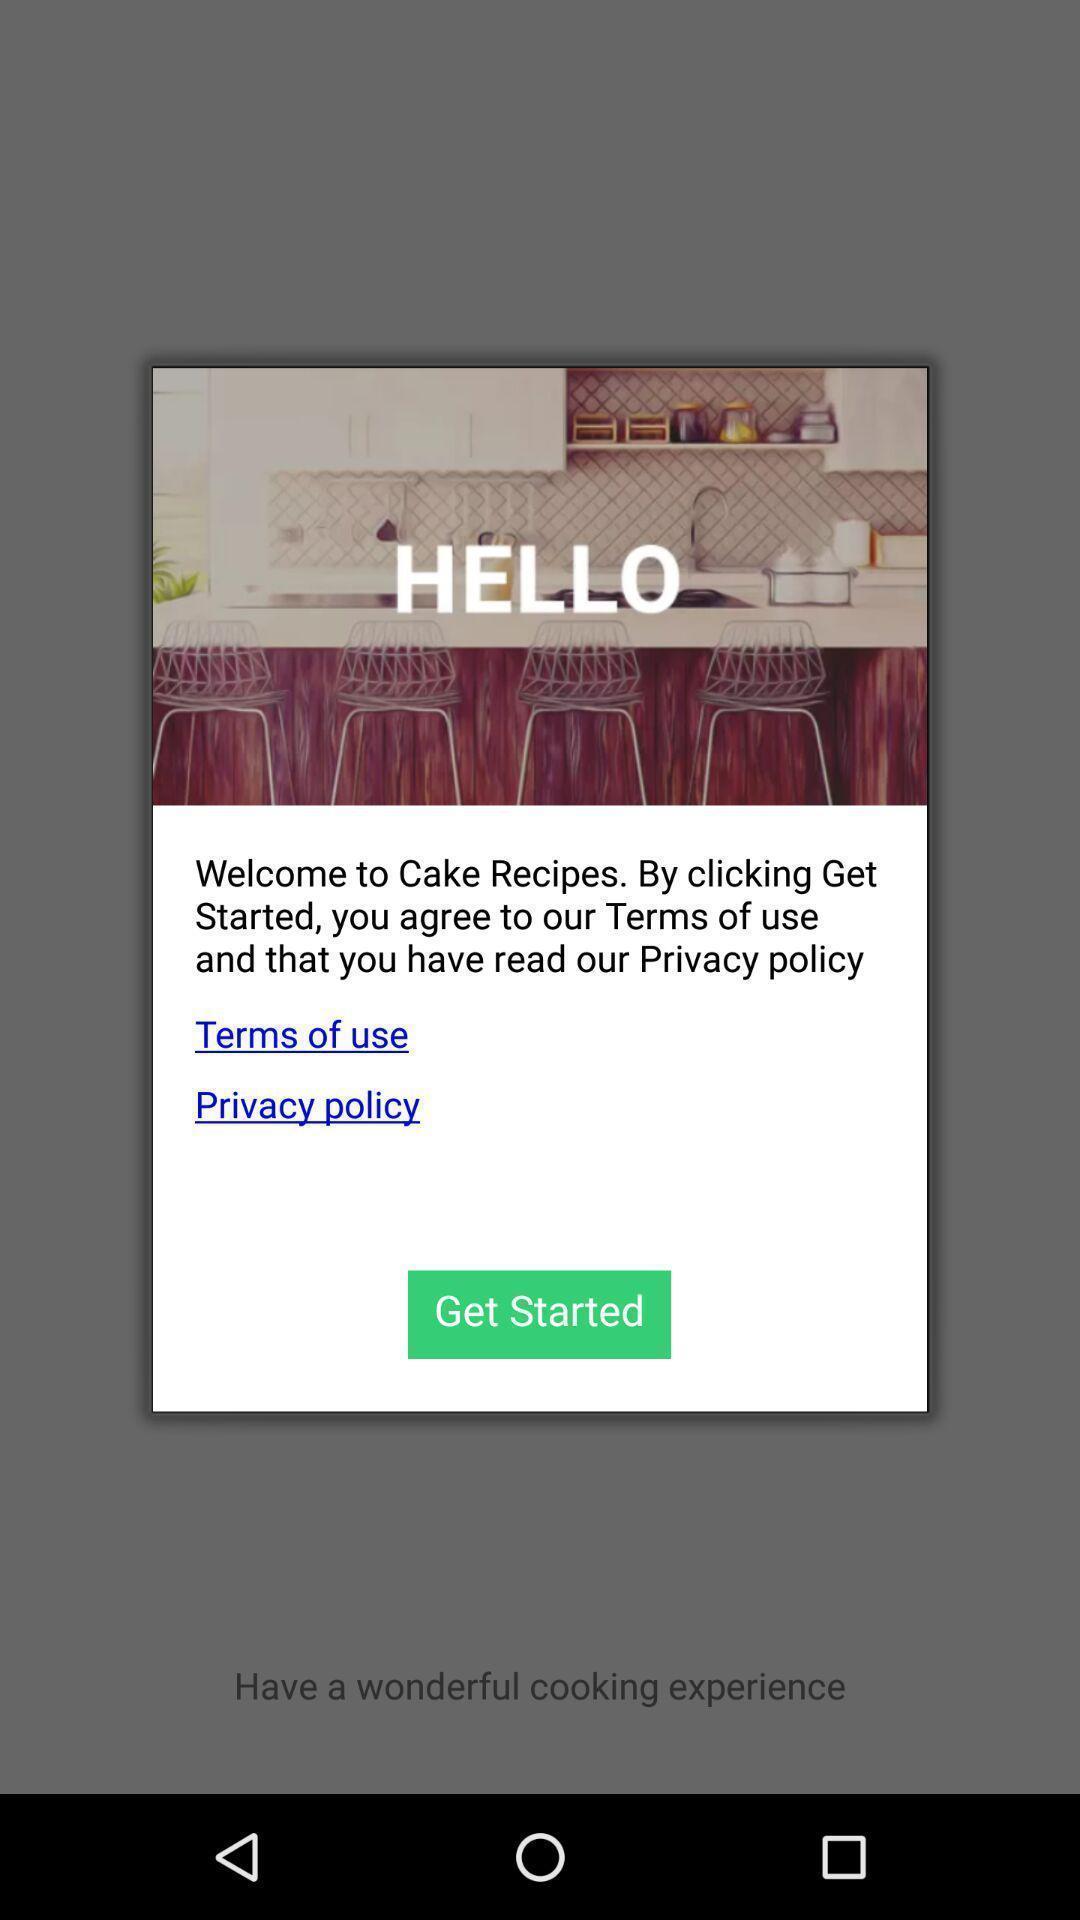Summarize the information in this screenshot. Welcome text of application for the cake order. 